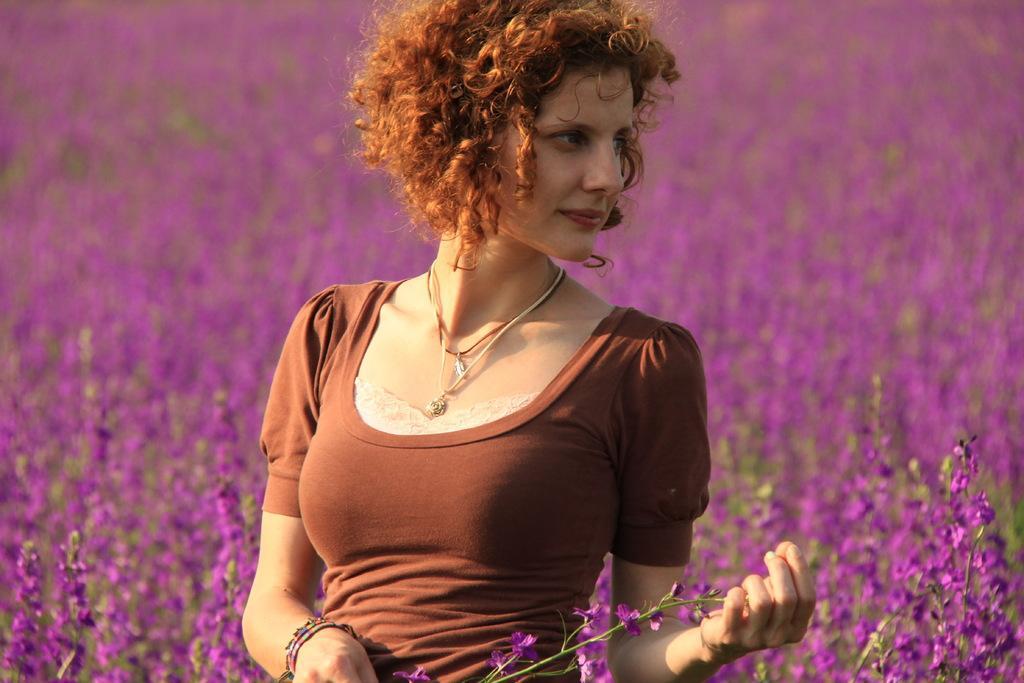How would you summarize this image in a sentence or two? In this picture there is a woman with brown dress is holding the flowers. At the bottom there are purple color flowers on the plants. 